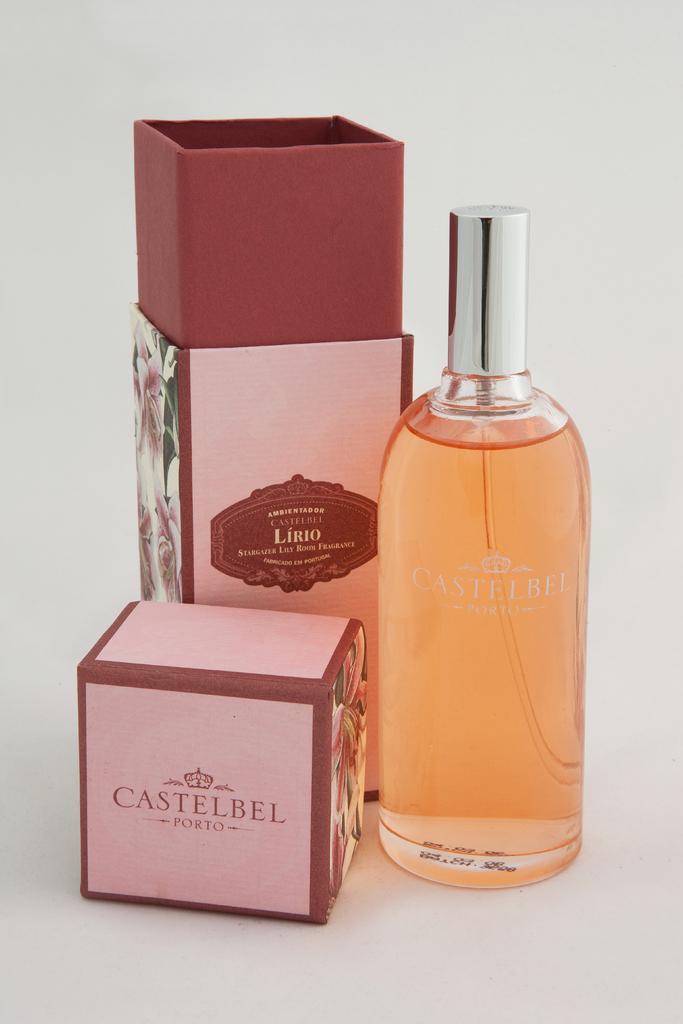How would you summarize this image in a sentence or two? It's a bottle with fluid in it. 